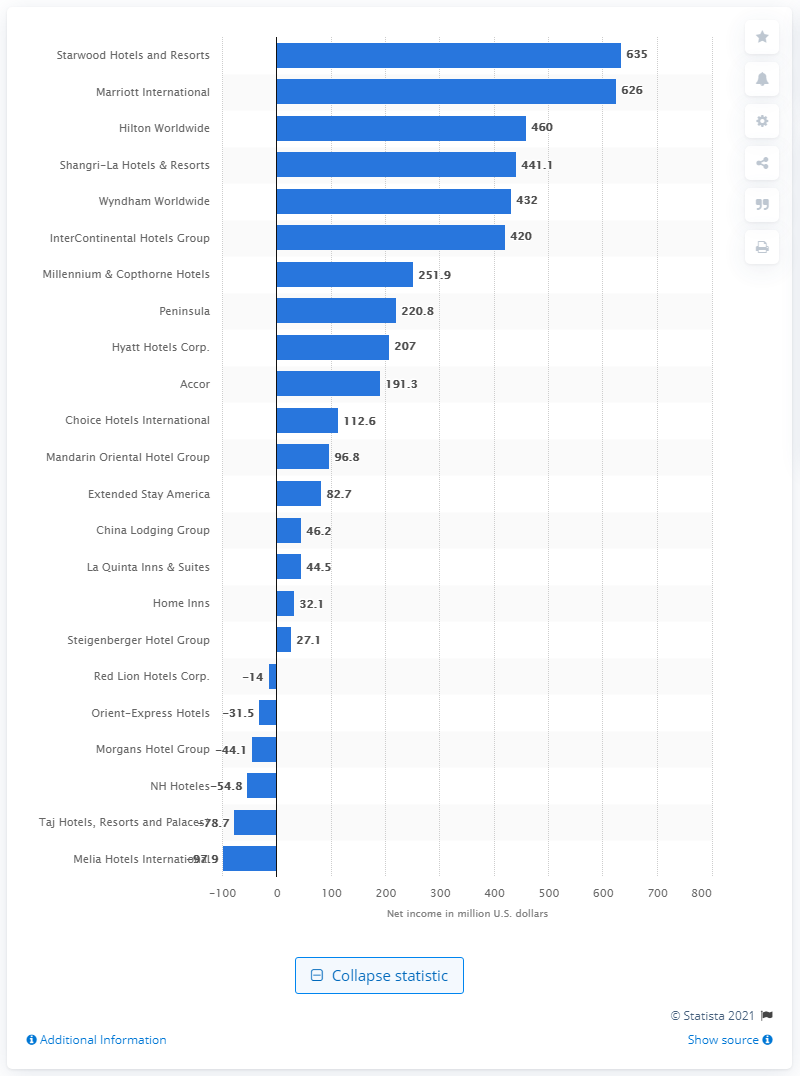Specify some key components in this picture. In 2013, the net income of Starwood Hotels and Resorts was $635 million. In 2013, Starwood Hotels and Resorts earned the largest net income among all hotel companies. 